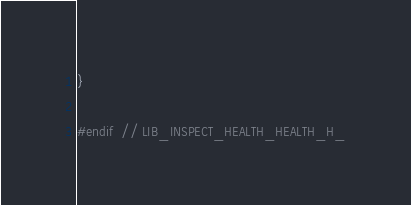Convert code to text. <code><loc_0><loc_0><loc_500><loc_500><_C_>}

#endif  // LIB_INSPECT_HEALTH_HEALTH_H_
</code> 